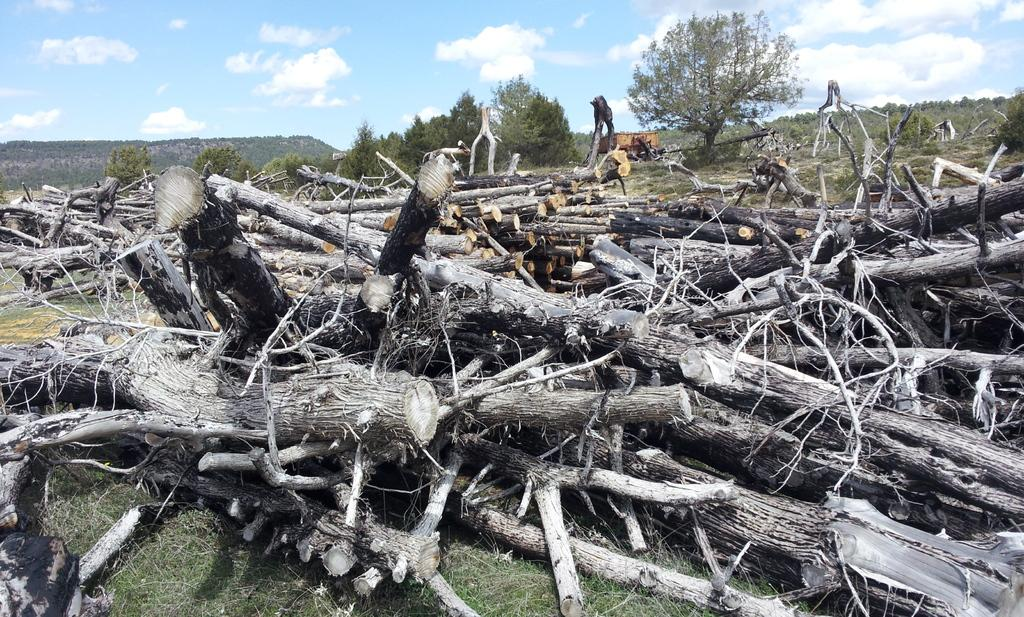What type of wooden pieces can be seen in the image? There are chopped wooden pieces in the image. What type of natural environment is depicted in the image? The image features trees and mountains. How many pigs can be seen grazing in the image? There are no pigs present in the image. What type of wound can be seen on the trees in the image? There are no wounds visible on the trees in the image. 